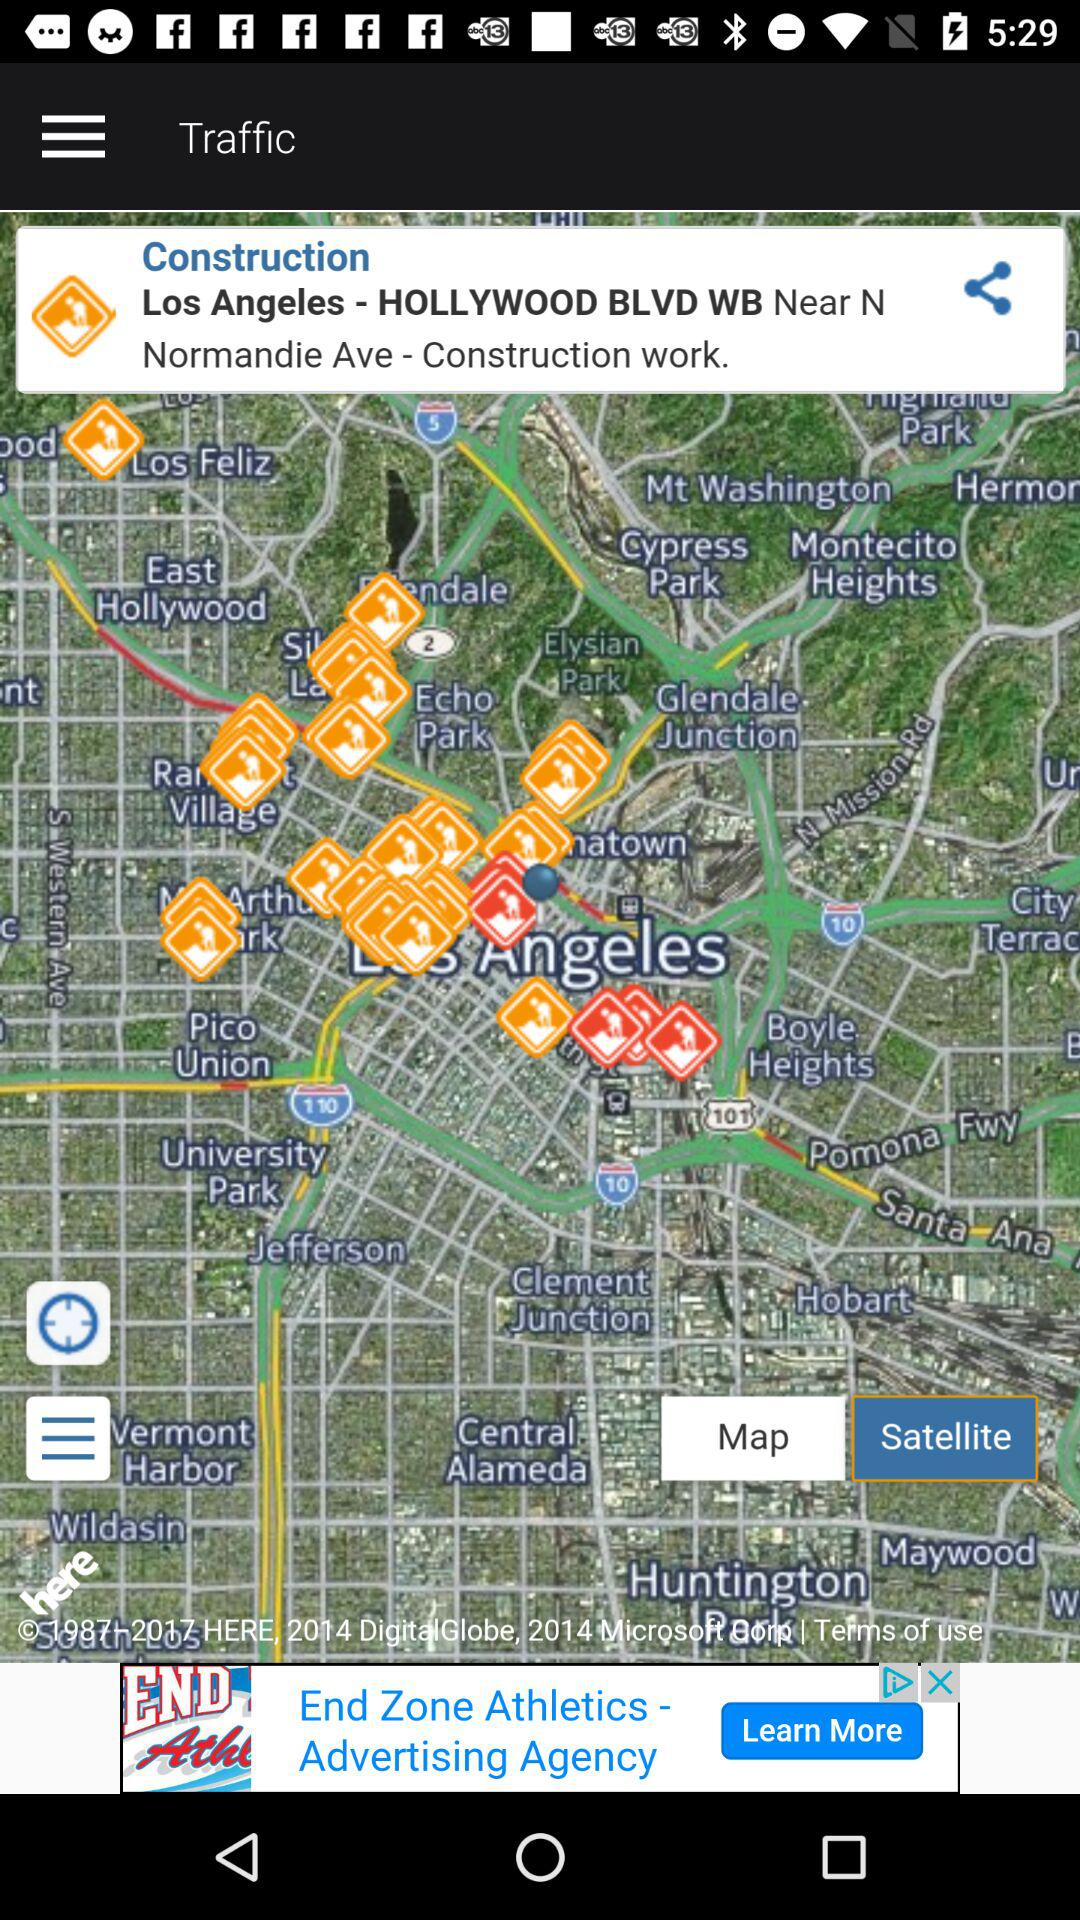What construction location name is mentioned? The mentioned construction location name is Los Angeles - HOLLYWOOD BLVD WB. 